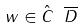<formula> <loc_0><loc_0><loc_500><loc_500>w \in \hat { C } \ \overline { D }</formula> 